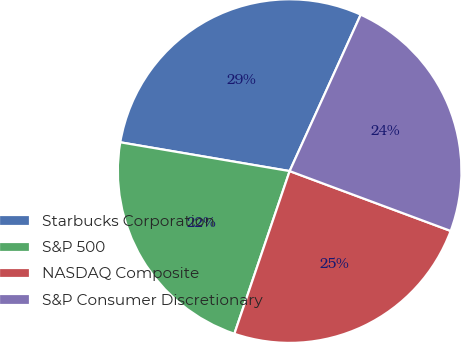Convert chart. <chart><loc_0><loc_0><loc_500><loc_500><pie_chart><fcel>Starbucks Corporation<fcel>S&P 500<fcel>NASDAQ Composite<fcel>S&P Consumer Discretionary<nl><fcel>29.11%<fcel>22.47%<fcel>24.55%<fcel>23.88%<nl></chart> 